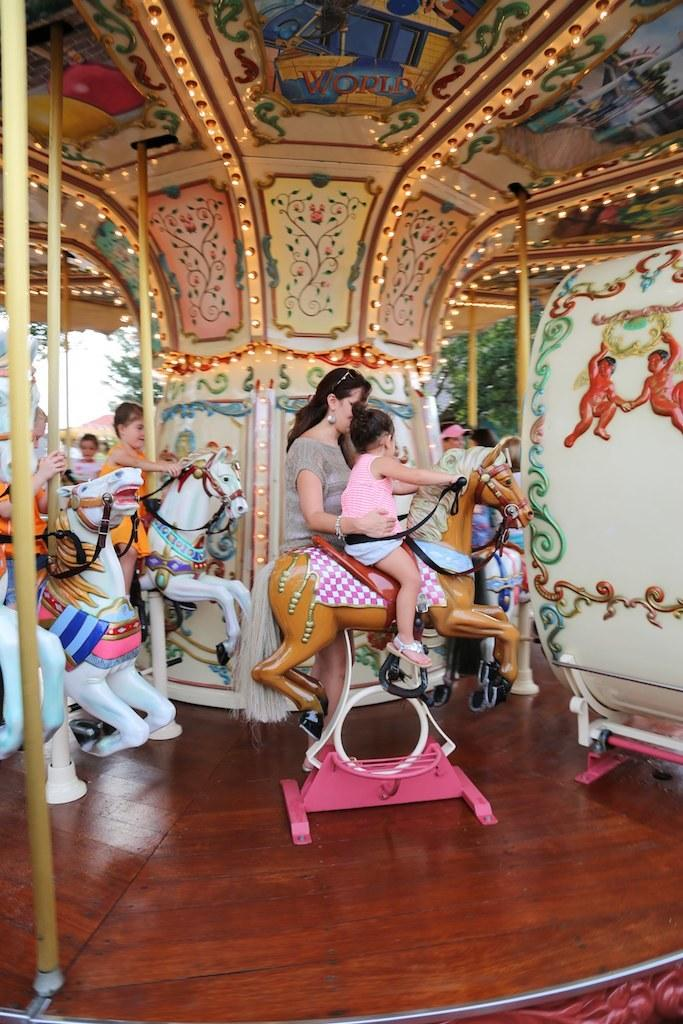What is: What can be seen in the image involving children? There are kids in the image, and they are riding carnival horses. What is the woman in the image doing? The woman is standing in the middle of the image. What is the material of the floor in the image? The floor is made of wood. How many icicles are hanging from the woman's hair in the image? There are no icicles present in the image, as it is not a winter scene and the woman's hair is not shown. 